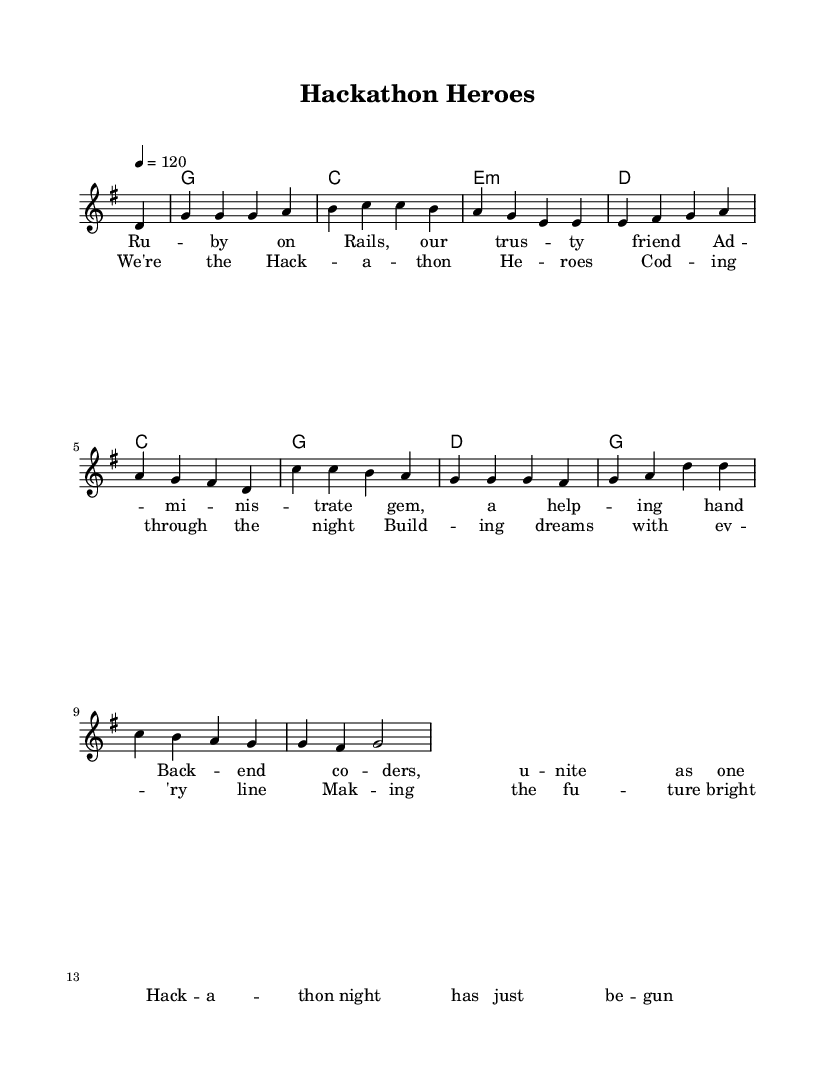What is the key signature of this music? The key signature is G major, which has one sharp (F#). This can be identified by looking at the key signature located at the beginning of the staff.
Answer: G major What is the time signature of this music? The time signature is 4/4, which can be found at the beginning of the sheet music next to the key signature. This indicates there are four beats per measure and the quarter note gets one beat.
Answer: 4/4 What is the tempo marking for this piece? The tempo marking indicates that the piece is to be played at 120 beats per minute. This is specified in the score before the melody begins, labeled as "4 = 120".
Answer: 120 How many measures are there in the melody? The melody has a total of 12 measures. This can be counted by looking at the melody section and identifying each group of notes separated by bar lines.
Answer: 12 What are the chord names that are played in the first four measures? The chord names for the first four measures are G major, C major, E minor, and D major. This is derived from the chord progression shown above the melody in the chord names staff.
Answer: G, C, E minor, D What is the main theme of the lyrics? The main theme of the lyrics centers on developers coming together for hackathons and collaborating to create something meaningful. The lyrics emphasize unity, support, and innovation during these events. This can be interpreted from the context of the verses and chorus provided.
Answer: Camaraderie What type of music do the rhythms in the melody reflect? The rhythms in the melody reflect a characteristic country rock feel, which typically features a blend of steady rhythms and upbeat melodies suitable for dancing. This can be seen in the consistent quarter note values that create a lively and engaging pace.
Answer: Country rock 